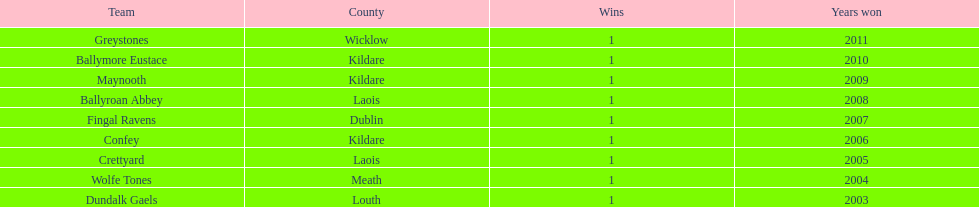Which county had the most number of wins? Kildare. 